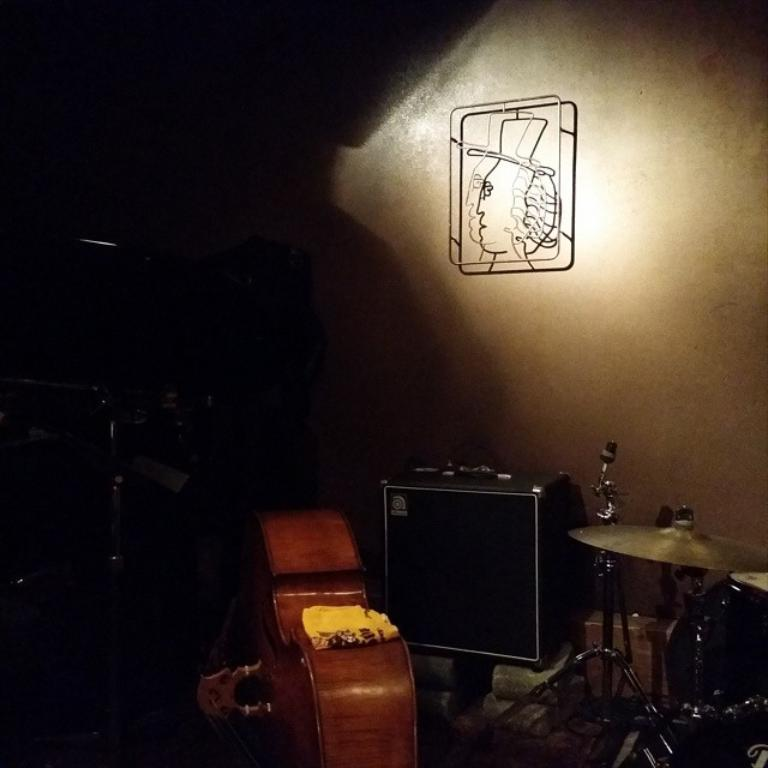What type of objects can be seen in the image? There are many musical instruments in the image. Can you describe a specific part of one of the musical instruments? There is a sound box in the image, which is a part of a stringed instrument. What can be seen in the background of the image? There is a wall in the background of the image. What type of gold expansion can be seen on the wall in the image? There is no gold expansion present in the image; the wall is a plain background for the musical instruments. 